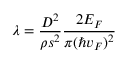<formula> <loc_0><loc_0><loc_500><loc_500>\lambda = \frac { D ^ { 2 } } { \rho s ^ { 2 } } \frac { 2 E _ { F } } { \pi ( \hbar { v } _ { F } ) ^ { 2 } }</formula> 